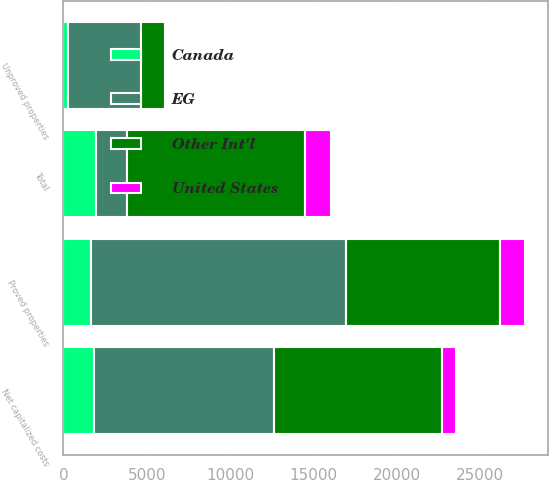Convert chart. <chart><loc_0><loc_0><loc_500><loc_500><stacked_bar_chart><ecel><fcel>Proved properties<fcel>Unproved properties<fcel>Total<fcel>Net capitalized costs<nl><fcel>EG<fcel>15288<fcel>4344<fcel>1838<fcel>10774<nl><fcel>Other Int'l<fcel>9209<fcel>1473<fcel>10682<fcel>10110<nl><fcel>United States<fcel>1545<fcel>23<fcel>1568<fcel>839<nl><fcel>Canada<fcel>1678<fcel>303<fcel>1981<fcel>1838<nl></chart> 